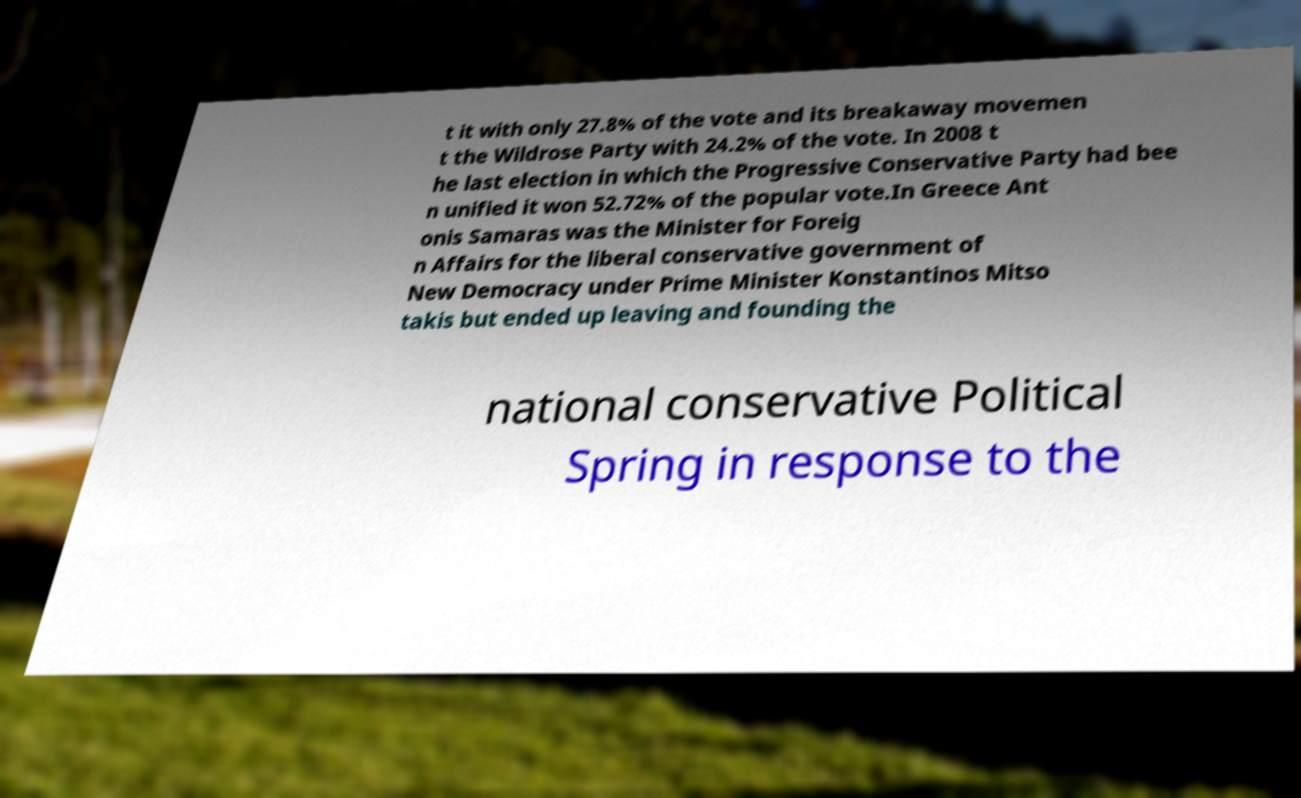For documentation purposes, I need the text within this image transcribed. Could you provide that? t it with only 27.8% of the vote and its breakaway movemen t the Wildrose Party with 24.2% of the vote. In 2008 t he last election in which the Progressive Conservative Party had bee n unified it won 52.72% of the popular vote.In Greece Ant onis Samaras was the Minister for Foreig n Affairs for the liberal conservative government of New Democracy under Prime Minister Konstantinos Mitso takis but ended up leaving and founding the national conservative Political Spring in response to the 